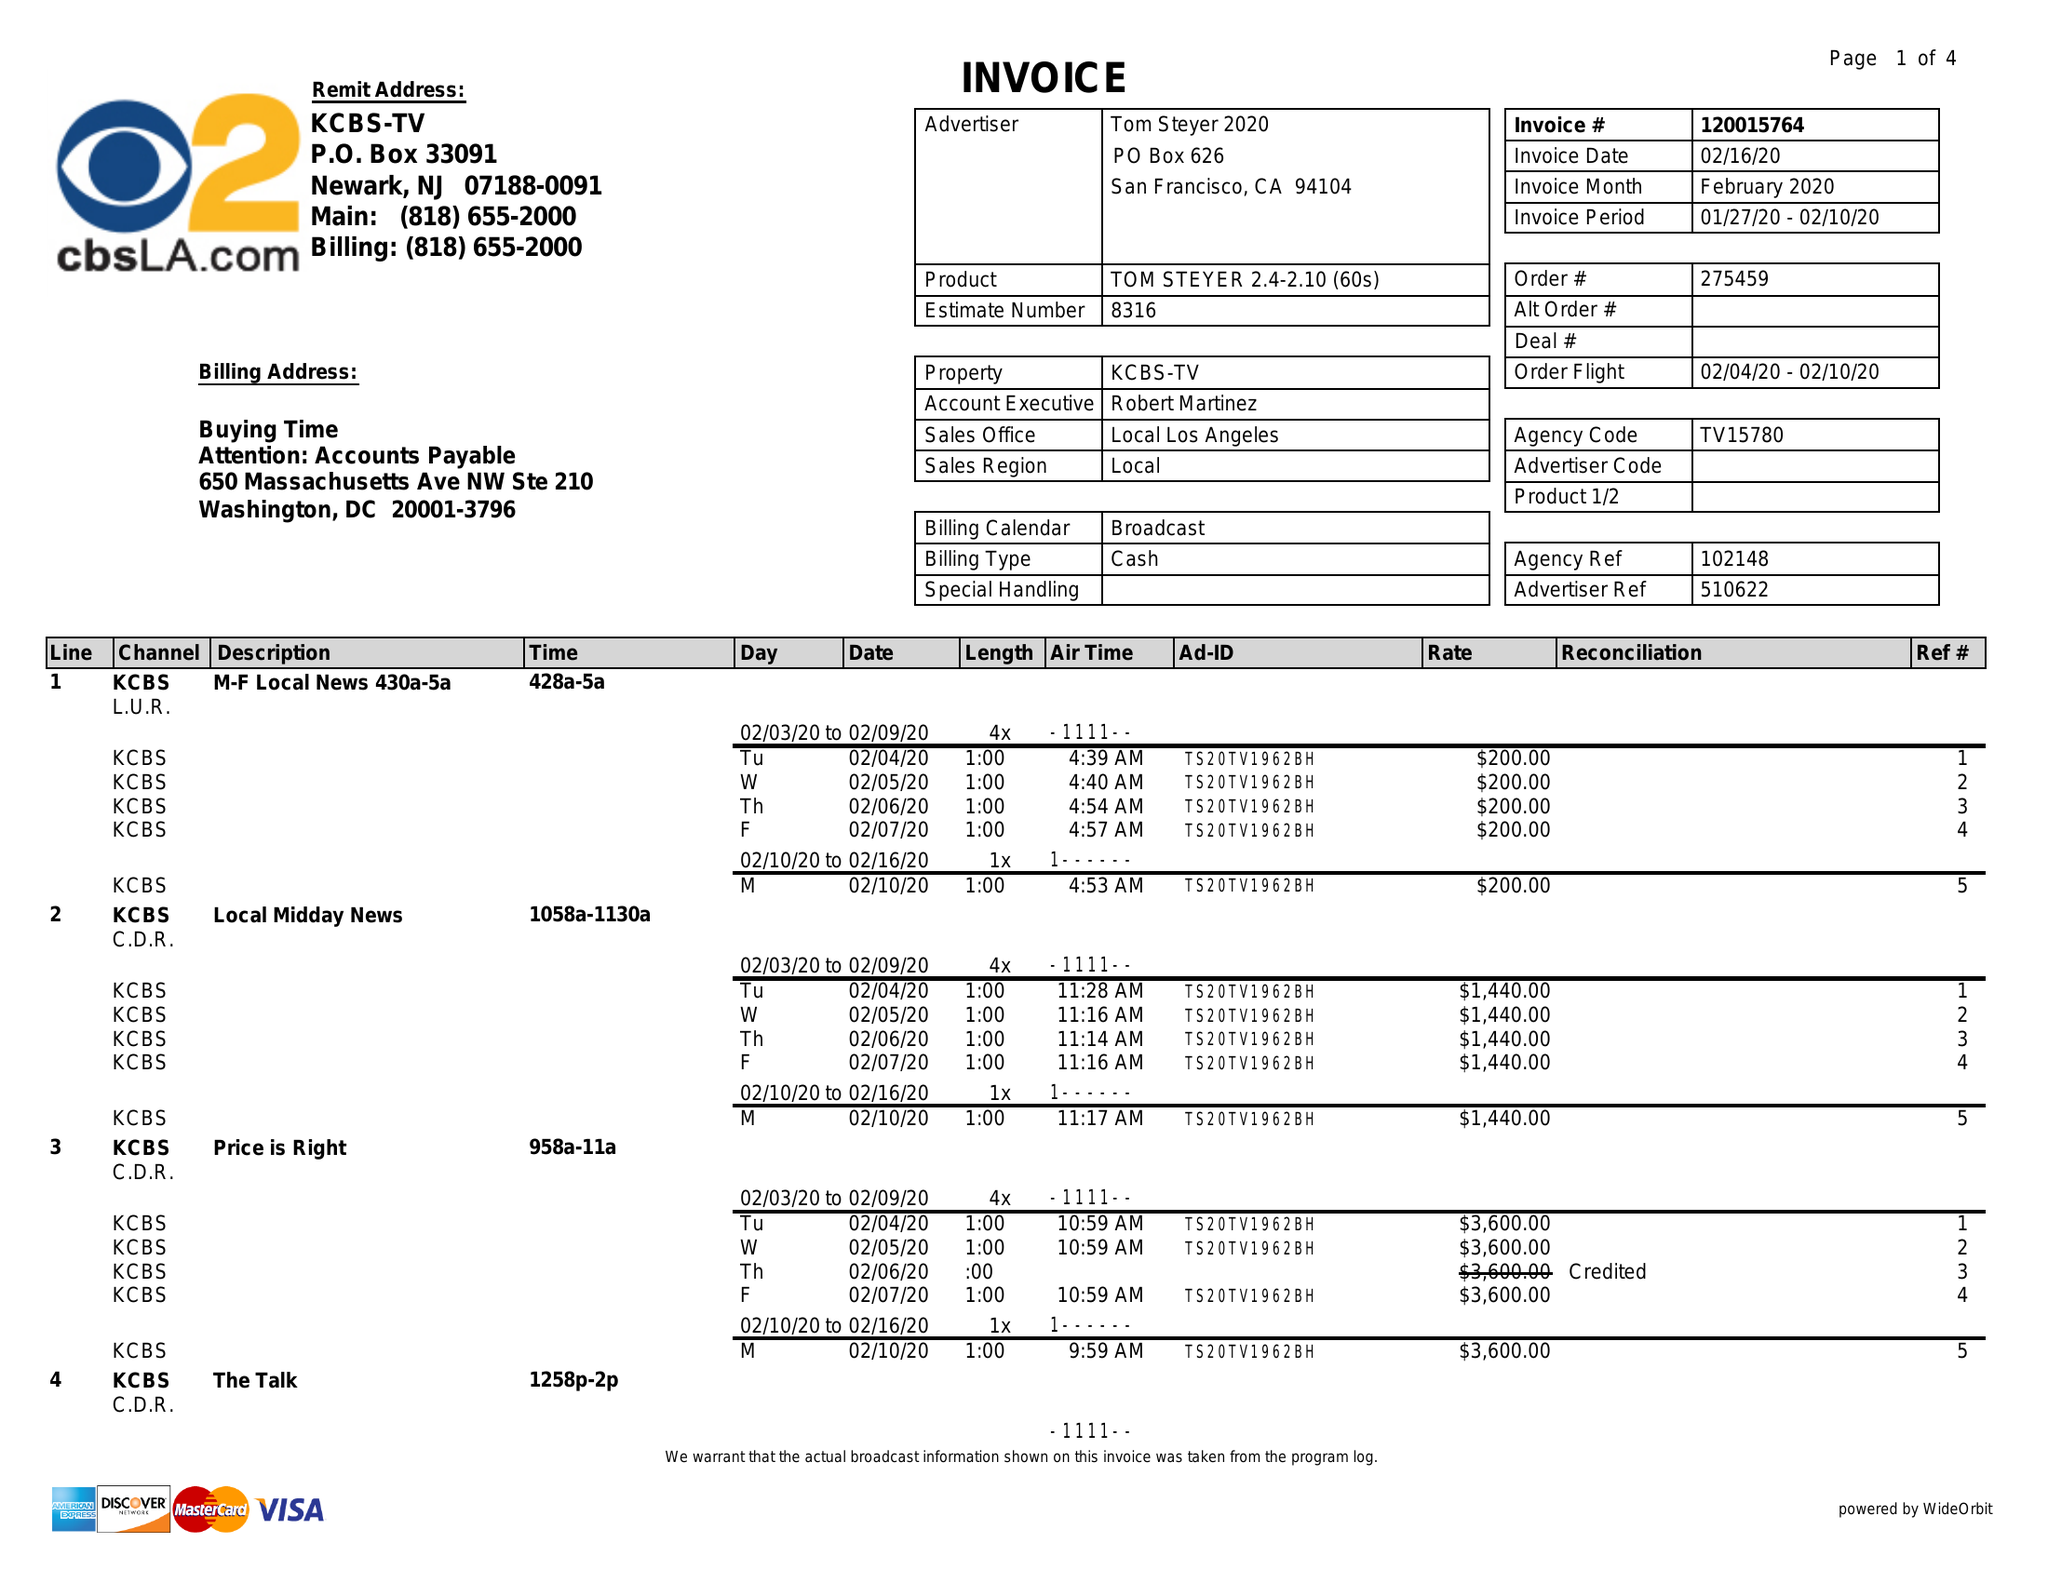What is the value for the advertiser?
Answer the question using a single word or phrase. TOM STEYER 2020 